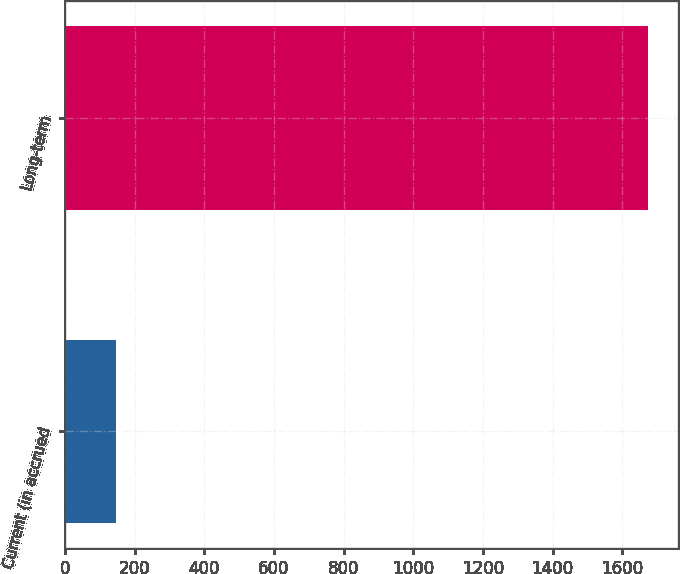Convert chart to OTSL. <chart><loc_0><loc_0><loc_500><loc_500><bar_chart><fcel>Current (in accrued<fcel>Long-term<nl><fcel>147<fcel>1675<nl></chart> 